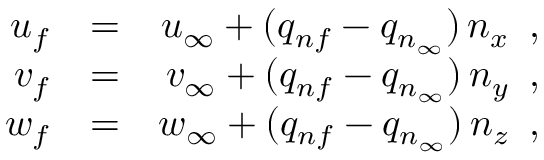<formula> <loc_0><loc_0><loc_500><loc_500>\begin{array} { r l r } { { u _ { f } } } & { = } } & { { u _ { \infty } + ( q _ { n f } - q _ { n _ { \infty } } ) \, n _ { x } \, , } } \\ { { v _ { f } } } & { = } } & { { v _ { \infty } + ( q _ { n f } - q _ { n _ { \infty } } ) \, n _ { y } \, , } } \\ { { w _ { f } } } & { = } } & { { w _ { \infty } + ( q _ { n f } - q _ { n _ { \infty } } ) \, n _ { z } \, , } } \end{array}</formula> 